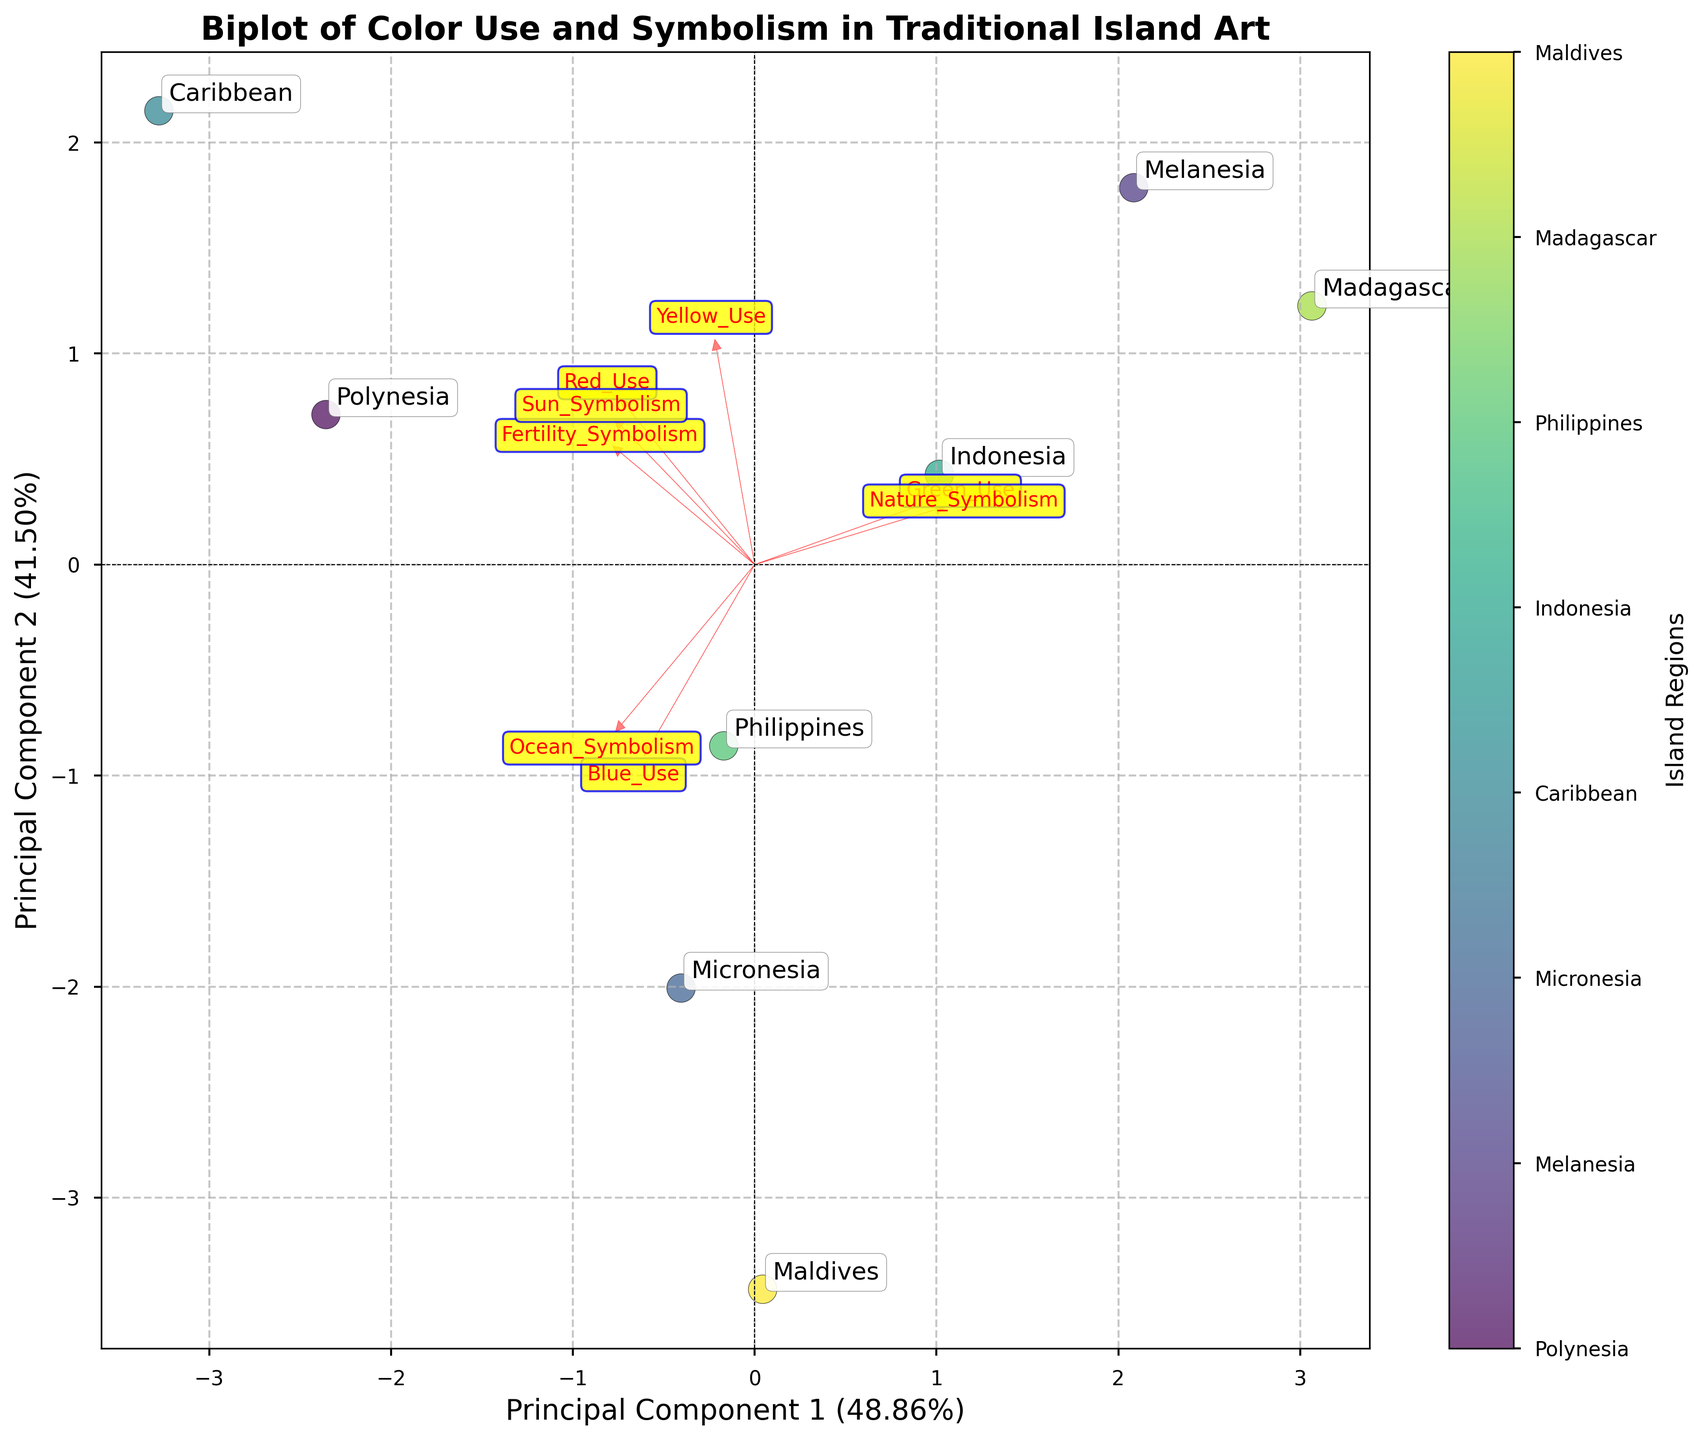What is the title of the plot? The title is located at the top of the plot and provides a succinct summary of what the plot is about.
Answer: Biplot of Color Use and Symbolism in Traditional Island Art How many island regions are represented in the plot? Each point on the plot represents a different island region. By counting the number of points, we find eight.
Answer: Eight Which island region is located closest to the center of the plot? Observing the plot, the island region closest to the origin (0,0) is identified by its label.
Answer: Maldives In terms of symbolic meanings, which feature shows the largest vector? The length of the vectors represents the contribution of each feature. By identifying the longest vector, we determine the feature.
Answer: Fertility_Symbolism Comparing Polynesia and Melanesia, which region has a higher use of Red in their traditional art? By examining the annotated labels and checking the direction and magnitude relevant to the Red_Use vector, we determine the higher value.
Answer: Polynesia Which features are positively correlated based on their loading vectors? Vectors pointing in the same or similar directions in a biplot indicate positive correlations. Observing these vectors, we identify the features.
Answer: Ocean_Symbolism and Blue_Use What is the second principal component's explained variance percentage? The percentage is displayed on the axis label of the second principal component.
Answer: 32% Which island region appears most distinct from the others in the first principal component? By evaluating the positions of the points along the first principal component axis, we identify the region that stands out.
Answer: Polynesia Which symbolic meaning is least associated with the use of Green? By examining the loading vectors, the vector for Green_Use is compared with others to determine the weakest association.
Answer: Sun_Symbolism How do the arrows help to interpret the relationship between the colors and symbolism in island art? Arrows (vectors) represent the features and their directions and lengths indicate their influence on the principal components.
Answer: They show the contribution and correlation of each color and symbolism to the principal components 